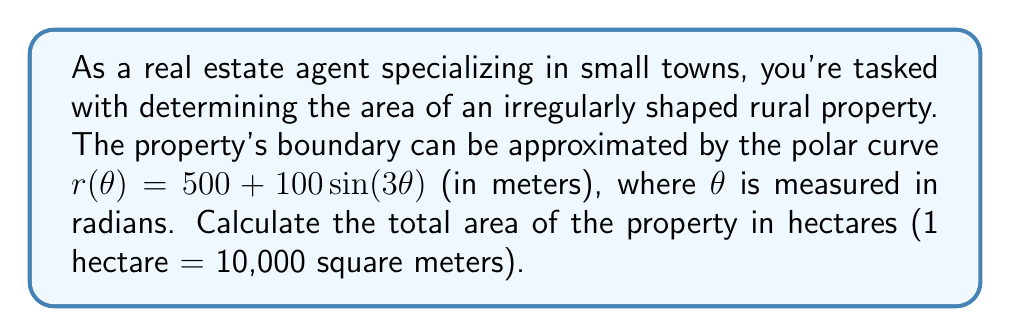Could you help me with this problem? To solve this problem, we'll use the formula for the area of a region in polar coordinates:

$$ A = \frac{1}{2} \int_{0}^{2\pi} [r(\theta)]^2 d\theta $$

1) First, let's square the given function:
   $$ [r(\theta)]^2 = (500 + 100\sin(3\theta))^2 = 250000 + 100000\sin(3\theta) + 10000\sin^2(3\theta) $$

2) Now, we integrate this function from 0 to 2π:
   $$ A = \frac{1}{2} \int_{0}^{2\pi} (250000 + 100000\sin(3\theta) + 10000\sin^2(3\theta)) d\theta $$

3) Let's integrate each term separately:
   - $\int_{0}^{2\pi} 250000 d\theta = 250000\theta |_{0}^{2\pi} = 500000\pi$
   - $\int_{0}^{2\pi} 100000\sin(3\theta) d\theta = -\frac{100000}{3}\cos(3\theta) |_{0}^{2\pi} = 0$
   - $\int_{0}^{2\pi} 10000\sin^2(3\theta) d\theta = 10000 \cdot \frac{\pi}{2} = 5000\pi$

4) Adding these results:
   $$ A = \frac{1}{2} (500000\pi + 0 + 5000\pi) = \frac{505000\pi}{2} $$

5) This gives us the area in square meters. To convert to hectares, we divide by 10000:
   $$ A_{hectares} = \frac{505000\pi}{20000} = 25.25\pi $$
Answer: The total area of the property is $25.25\pi$ hectares, or approximately 79.33 hectares. 